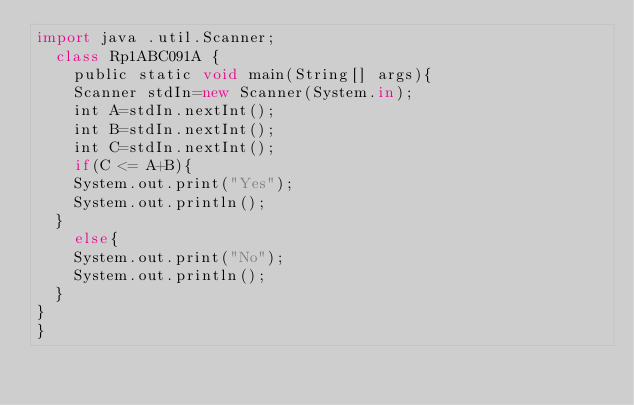<code> <loc_0><loc_0><loc_500><loc_500><_JavaScript_>import java .util.Scanner;
  class Rp1ABC091A {
    public static void main(String[] args){
    Scanner stdIn=new Scanner(System.in);
    int A=stdIn.nextInt();
    int B=stdIn.nextInt();
    int C=stdIn.nextInt();
    if(C <= A+B){
    System.out.print("Yes");
    System.out.println();
  }
    else{
    System.out.print("No");
    System.out.println();
  }
}
}</code> 